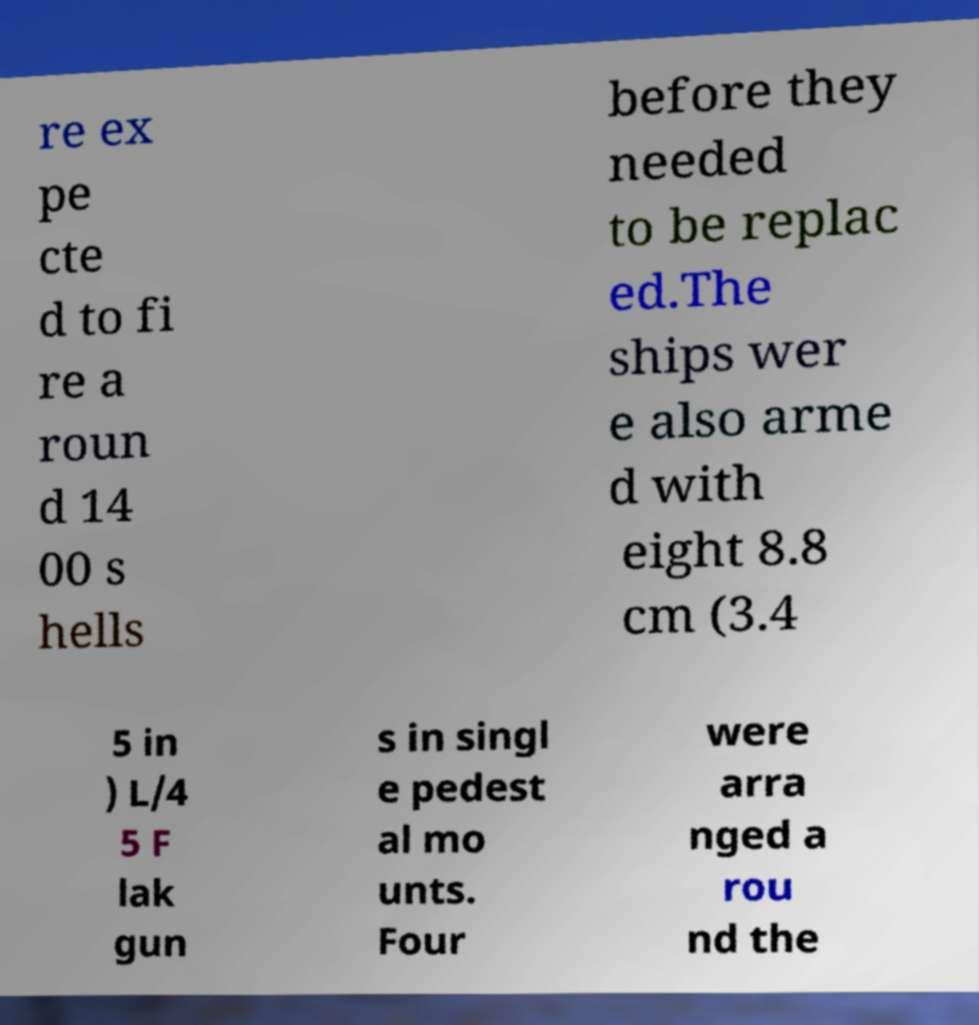Could you extract and type out the text from this image? re ex pe cte d to fi re a roun d 14 00 s hells before they needed to be replac ed.The ships wer e also arme d with eight 8.8 cm (3.4 5 in ) L/4 5 F lak gun s in singl e pedest al mo unts. Four were arra nged a rou nd the 